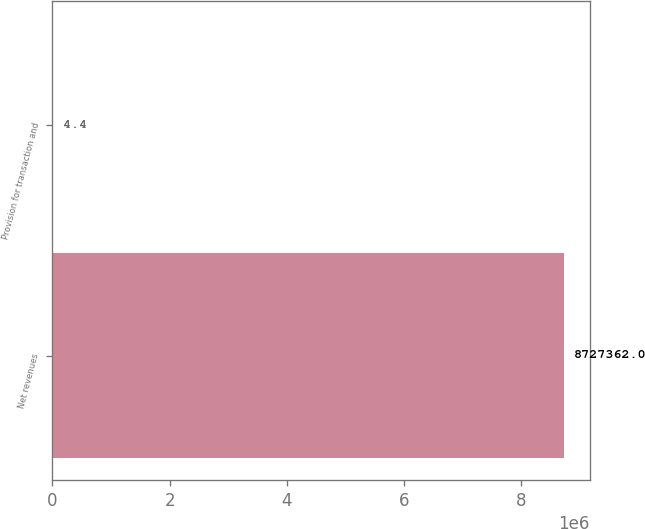Convert chart to OTSL. <chart><loc_0><loc_0><loc_500><loc_500><bar_chart><fcel>Net revenues<fcel>Provision for transaction and<nl><fcel>8.72736e+06<fcel>4.4<nl></chart> 